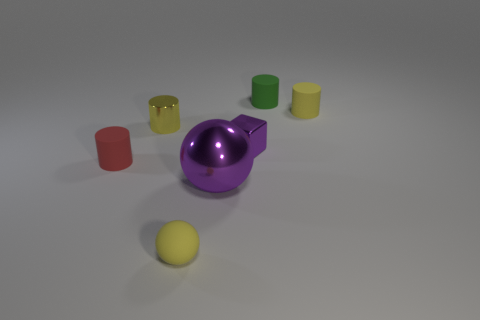Subtract all tiny red matte cylinders. How many cylinders are left? 3 Subtract all cyan spheres. How many yellow cylinders are left? 2 Subtract all green cylinders. How many cylinders are left? 3 Add 1 yellow cylinders. How many objects exist? 8 Subtract all blocks. How many objects are left? 6 Subtract all blue cylinders. Subtract all purple spheres. How many cylinders are left? 4 Subtract all cubes. Subtract all tiny blocks. How many objects are left? 5 Add 6 matte cylinders. How many matte cylinders are left? 9 Add 7 green things. How many green things exist? 8 Subtract 0 cyan spheres. How many objects are left? 7 